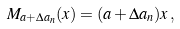Convert formula to latex. <formula><loc_0><loc_0><loc_500><loc_500>M _ { a + \Delta a _ { n } } ( x ) = ( a + \Delta a _ { n } ) x \, ,</formula> 